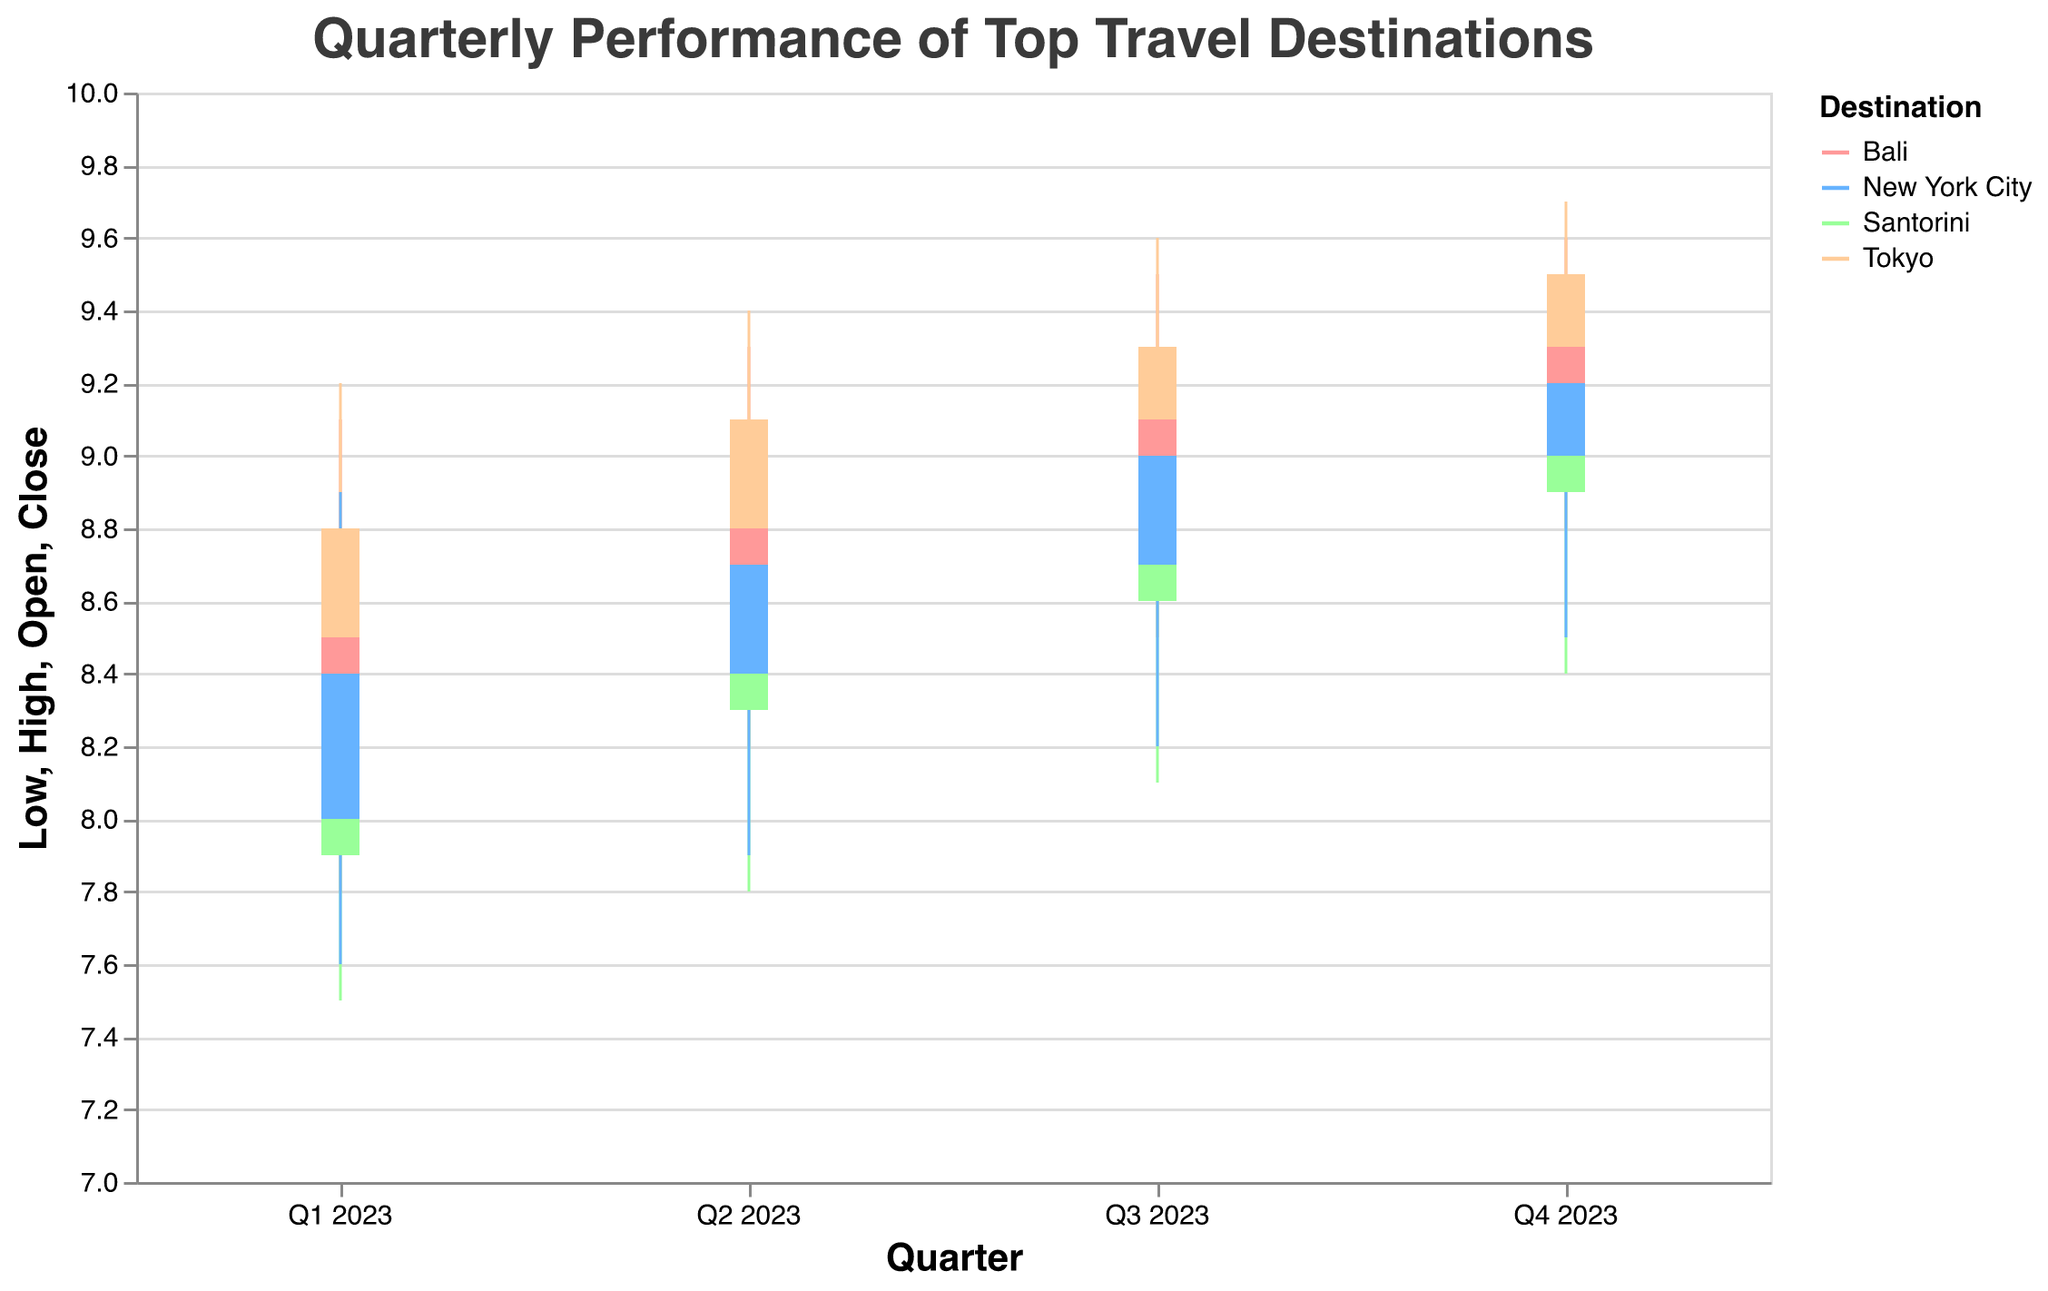What's the title of the figure? The title of the figure is located at the top and provides a brief description of what the data represents. In this case, the title is "Quarterly Performance of Top Travel Destinations".
Answer: Quarterly Performance of Top Travel Destinations Which destination had the highest closing value in Q4 2023? To find the highest closing value, examine the end value for each destination in Q4 2023. The closing values are 9.4 for Bali, 9.1 for Santorini, 9.5 for Tokyo, and 9.2 for New York City.
Answer: Tokyo Which destination showed the greatest range between high and low values in Q2 2023? The range is calculated by subtracting the low value from the high value. In Q2 2023, the ranges are: Bali (9.3 - 8.2 = 1.1), Santorini (9.0 - 7.8 = 1.2), Tokyo (9.4 - 8.3 = 1.1), and New York City (9.1 - 7.9 = 1.2). Santorini and New York City both display the greatest range of 1.2.
Answer: Santorini and New York City What is the average opening value for New York City across all quarters? The opening values for New York City are 8.0, 8.4, 8.7, and 9.0 across the four quarters. To find the average, sum these values and divide by the number of quarters: (8.0 + 8.4 + 8.7 + 9.0) / 4 = 34.1 / 4 = 8.525.
Answer: 8.525 Compare the influencer score of Bali in Q1 2023 to that of Tokyo in Q4 2023. Which is higher? To compare the influencer scores, look at the given influencer scores for Bali in Q1 2023 (92) and for Tokyo in Q4 2023 (99). Tokyo has the higher influencer score.
Answer: Tokyo Which destination showed a consistent increase in closing values across all four quarters? To evaluate consistency, we need to see if the closing values continuously increase from quarter to quarter. Bali shows an increase from 8.7 to 9.0 to 9.2 to 9.4.
Answer: Bali During which quarter did Santorini have its lowest opening value, and what was it? Examine the opening values of Santorini for all quarters: Q1 2023 (7.9), Q2 2023 (8.3), Q3 2023 (8.6), Q4 2023 (8.9). The lowest opening value was in Q1 2023 at 7.9.
Answer: Q1 2023 What is the difference between the closing values of Tokyo and New York City in Q3 2023? The closing value for Tokyo in Q3 2023 is 9.3, and for New York City, it is 9.0. The difference is 9.3 - 9.0 = 0.3.
Answer: 0.3 Which destination had the highest high value in Q1 2023? The high values for Q1 2023 are Bali (9.1), Santorini (8.8), Tokyo (9.2), and New York City (8.9). Therefore, Tokyo had the highest high value.
Answer: Tokyo What was the closing value of Santorini in Q4 2023 and how did it compare to its opening value in the same quarter? Santorini’s closing value in Q4 2023 is 9.1, and the opening value is 8.9. To compare, the closing value is higher by 0.2.
Answer: 9.1, higher by 0.2 